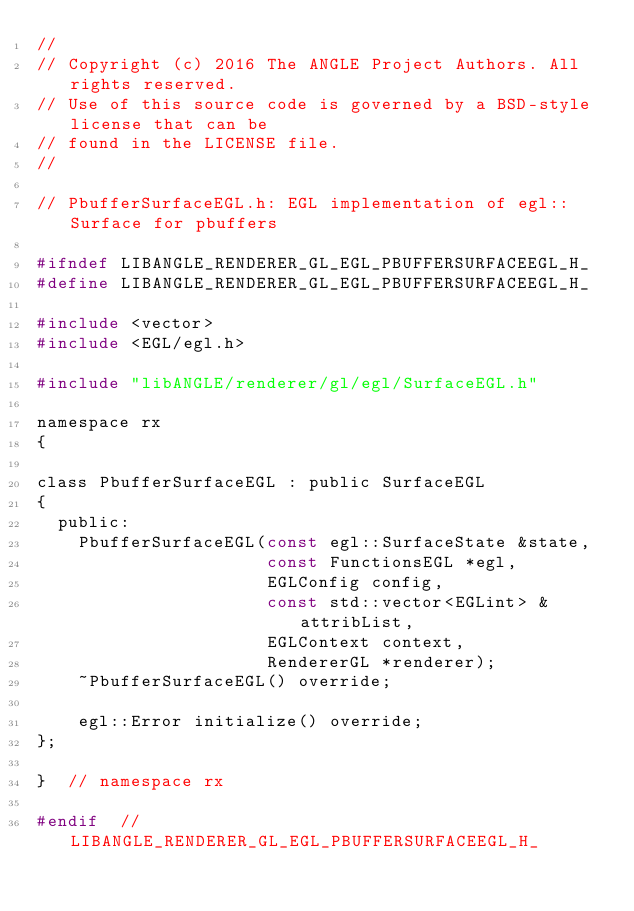<code> <loc_0><loc_0><loc_500><loc_500><_C_>//
// Copyright (c) 2016 The ANGLE Project Authors. All rights reserved.
// Use of this source code is governed by a BSD-style license that can be
// found in the LICENSE file.
//

// PbufferSurfaceEGL.h: EGL implementation of egl::Surface for pbuffers

#ifndef LIBANGLE_RENDERER_GL_EGL_PBUFFERSURFACEEGL_H_
#define LIBANGLE_RENDERER_GL_EGL_PBUFFERSURFACEEGL_H_

#include <vector>
#include <EGL/egl.h>

#include "libANGLE/renderer/gl/egl/SurfaceEGL.h"

namespace rx
{

class PbufferSurfaceEGL : public SurfaceEGL
{
  public:
    PbufferSurfaceEGL(const egl::SurfaceState &state,
                      const FunctionsEGL *egl,
                      EGLConfig config,
                      const std::vector<EGLint> &attribList,
                      EGLContext context,
                      RendererGL *renderer);
    ~PbufferSurfaceEGL() override;

    egl::Error initialize() override;
};

}  // namespace rx

#endif  // LIBANGLE_RENDERER_GL_EGL_PBUFFERSURFACEEGL_H_
</code> 